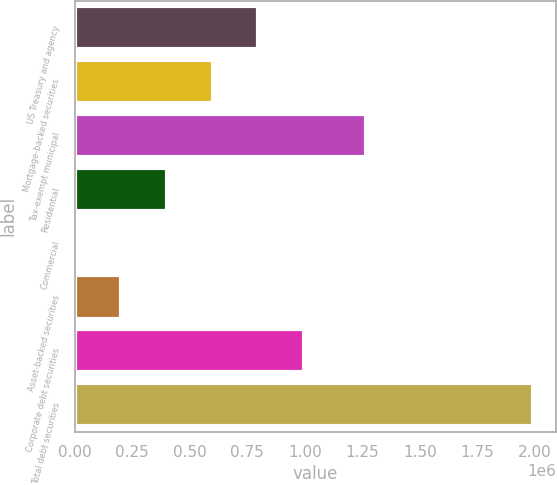<chart> <loc_0><loc_0><loc_500><loc_500><bar_chart><fcel>US Treasury and agency<fcel>Mortgage-backed securities<fcel>Tax-exempt municipal<fcel>Residential<fcel>Commercial<fcel>Asset-backed securities<fcel>Corporate debt securities<fcel>Total debt securities<nl><fcel>798302<fcel>599414<fcel>1.26603e+06<fcel>400527<fcel>2752<fcel>201640<fcel>997190<fcel>1.99163e+06<nl></chart> 